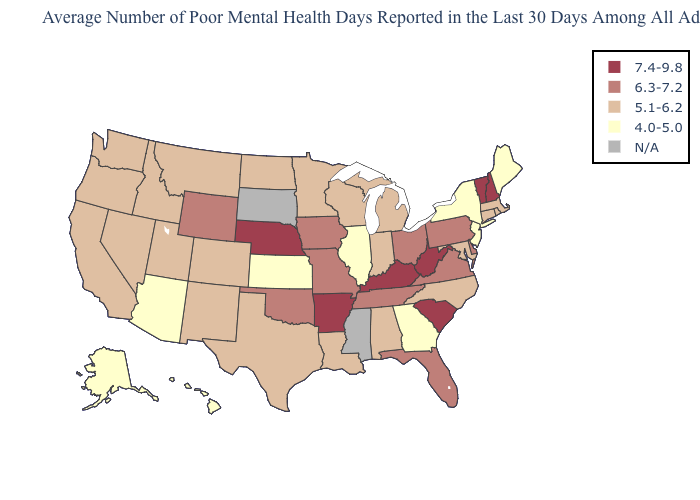Does Vermont have the highest value in the Northeast?
Give a very brief answer. Yes. Name the states that have a value in the range 5.1-6.2?
Short answer required. Alabama, California, Colorado, Connecticut, Idaho, Indiana, Louisiana, Maryland, Massachusetts, Michigan, Minnesota, Montana, Nevada, New Mexico, North Carolina, North Dakota, Oregon, Rhode Island, Texas, Utah, Washington, Wisconsin. Among the states that border Missouri , which have the lowest value?
Short answer required. Illinois, Kansas. What is the lowest value in the MidWest?
Short answer required. 4.0-5.0. What is the lowest value in states that border Louisiana?
Short answer required. 5.1-6.2. Which states have the lowest value in the MidWest?
Short answer required. Illinois, Kansas. Name the states that have a value in the range N/A?
Give a very brief answer. Mississippi, South Dakota. Among the states that border Connecticut , does New York have the lowest value?
Keep it brief. Yes. What is the value of New York?
Keep it brief. 4.0-5.0. Among the states that border Tennessee , does Kentucky have the highest value?
Answer briefly. Yes. Among the states that border Oregon , which have the highest value?
Give a very brief answer. California, Idaho, Nevada, Washington. Among the states that border Nebraska , which have the lowest value?
Keep it brief. Kansas. Name the states that have a value in the range 6.3-7.2?
Quick response, please. Delaware, Florida, Iowa, Missouri, Ohio, Oklahoma, Pennsylvania, Tennessee, Virginia, Wyoming. What is the highest value in states that border Nebraska?
Answer briefly. 6.3-7.2. Does Idaho have the highest value in the USA?
Answer briefly. No. 